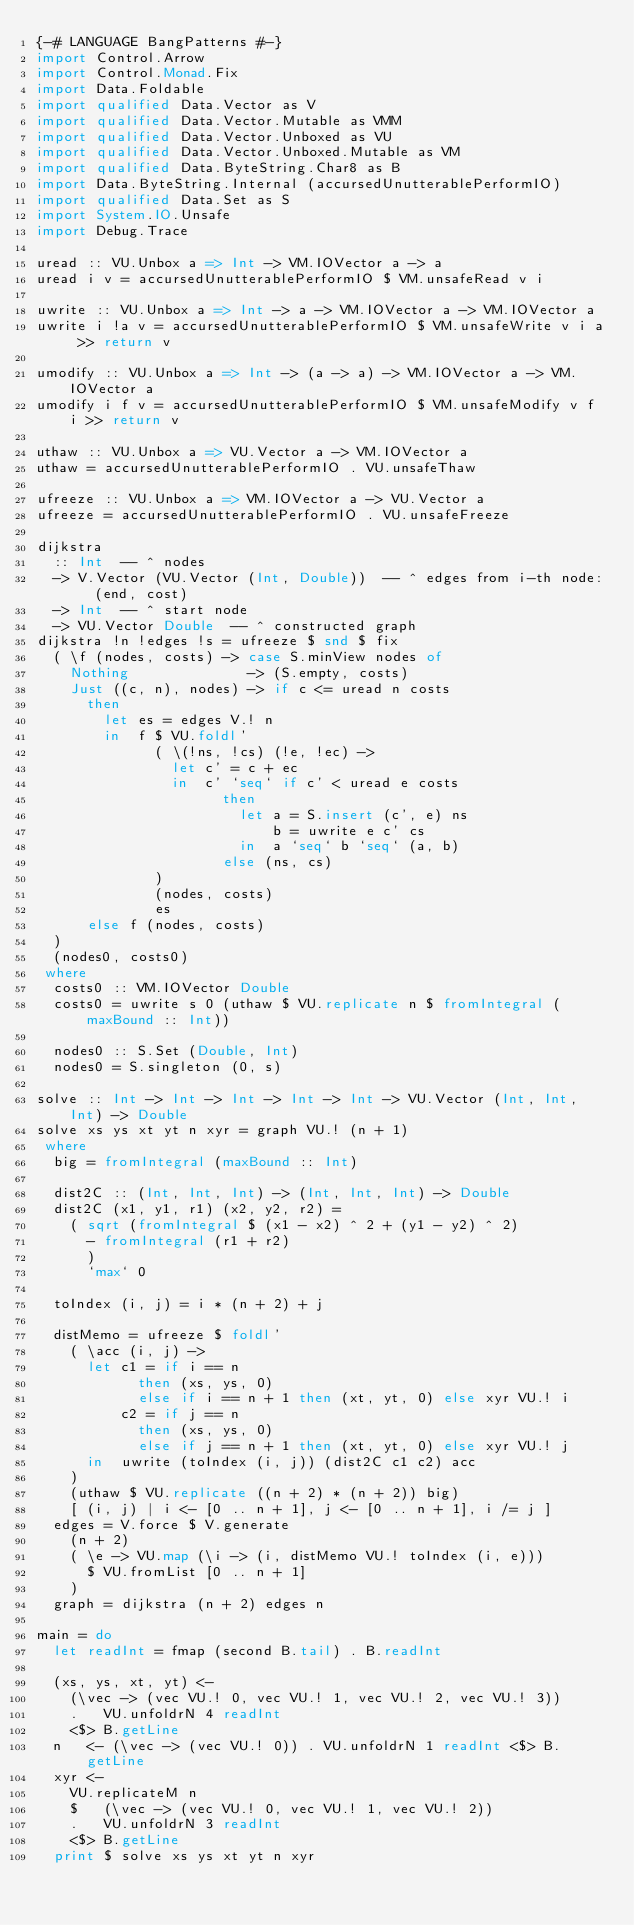Convert code to text. <code><loc_0><loc_0><loc_500><loc_500><_Haskell_>{-# LANGUAGE BangPatterns #-}
import Control.Arrow
import Control.Monad.Fix
import Data.Foldable
import qualified Data.Vector as V
import qualified Data.Vector.Mutable as VMM
import qualified Data.Vector.Unboxed as VU
import qualified Data.Vector.Unboxed.Mutable as VM
import qualified Data.ByteString.Char8 as B
import Data.ByteString.Internal (accursedUnutterablePerformIO)
import qualified Data.Set as S
import System.IO.Unsafe
import Debug.Trace

uread :: VU.Unbox a => Int -> VM.IOVector a -> a
uread i v = accursedUnutterablePerformIO $ VM.unsafeRead v i

uwrite :: VU.Unbox a => Int -> a -> VM.IOVector a -> VM.IOVector a
uwrite i !a v = accursedUnutterablePerformIO $ VM.unsafeWrite v i a >> return v

umodify :: VU.Unbox a => Int -> (a -> a) -> VM.IOVector a -> VM.IOVector a
umodify i f v = accursedUnutterablePerformIO $ VM.unsafeModify v f i >> return v

uthaw :: VU.Unbox a => VU.Vector a -> VM.IOVector a
uthaw = accursedUnutterablePerformIO . VU.unsafeThaw

ufreeze :: VU.Unbox a => VM.IOVector a -> VU.Vector a
ufreeze = accursedUnutterablePerformIO . VU.unsafeFreeze

dijkstra
  :: Int  -- ^ nodes
  -> V.Vector (VU.Vector (Int, Double))  -- ^ edges from i-th node: (end, cost)
  -> Int  -- ^ start node
  -> VU.Vector Double  -- ^ constructed graph
dijkstra !n !edges !s = ufreeze $ snd $ fix
  ( \f (nodes, costs) -> case S.minView nodes of
    Nothing              -> (S.empty, costs)
    Just ((c, n), nodes) -> if c <= uread n costs
      then
        let es = edges V.! n
        in  f $ VU.foldl'
              ( \(!ns, !cs) (!e, !ec) ->
                let c' = c + ec
                in  c' `seq` if c' < uread e costs
                      then
                        let a = S.insert (c', e) ns
                            b = uwrite e c' cs
                        in  a `seq` b `seq` (a, b)
                      else (ns, cs)
              )
              (nodes, costs)
              es
      else f (nodes, costs)
  )
  (nodes0, costs0)
 where
  costs0 :: VM.IOVector Double
  costs0 = uwrite s 0 (uthaw $ VU.replicate n $ fromIntegral (maxBound :: Int))

  nodes0 :: S.Set (Double, Int)
  nodes0 = S.singleton (0, s)

solve :: Int -> Int -> Int -> Int -> Int -> VU.Vector (Int, Int, Int) -> Double
solve xs ys xt yt n xyr = graph VU.! (n + 1)
 where
  big = fromIntegral (maxBound :: Int)

  dist2C :: (Int, Int, Int) -> (Int, Int, Int) -> Double
  dist2C (x1, y1, r1) (x2, y2, r2) =
    ( sqrt (fromIntegral $ (x1 - x2) ^ 2 + (y1 - y2) ^ 2)
      - fromIntegral (r1 + r2)
      )
      `max` 0

  toIndex (i, j) = i * (n + 2) + j

  distMemo = ufreeze $ foldl'
    ( \acc (i, j) ->
      let c1 = if i == n
            then (xs, ys, 0)
            else if i == n + 1 then (xt, yt, 0) else xyr VU.! i
          c2 = if j == n
            then (xs, ys, 0)
            else if j == n + 1 then (xt, yt, 0) else xyr VU.! j
      in  uwrite (toIndex (i, j)) (dist2C c1 c2) acc
    )
    (uthaw $ VU.replicate ((n + 2) * (n + 2)) big)
    [ (i, j) | i <- [0 .. n + 1], j <- [0 .. n + 1], i /= j ]
  edges = V.force $ V.generate
    (n + 2)
    ( \e -> VU.map (\i -> (i, distMemo VU.! toIndex (i, e)))
      $ VU.fromList [0 .. n + 1]
    )
  graph = dijkstra (n + 2) edges n

main = do
  let readInt = fmap (second B.tail) . B.readInt

  (xs, ys, xt, yt) <-
    (\vec -> (vec VU.! 0, vec VU.! 1, vec VU.! 2, vec VU.! 3))
    .   VU.unfoldrN 4 readInt
    <$> B.getLine
  n   <- (\vec -> (vec VU.! 0)) . VU.unfoldrN 1 readInt <$> B.getLine
  xyr <-
    VU.replicateM n
    $   (\vec -> (vec VU.! 0, vec VU.! 1, vec VU.! 2))
    .   VU.unfoldrN 3 readInt
    <$> B.getLine
  print $ solve xs ys xt yt n xyr
</code> 